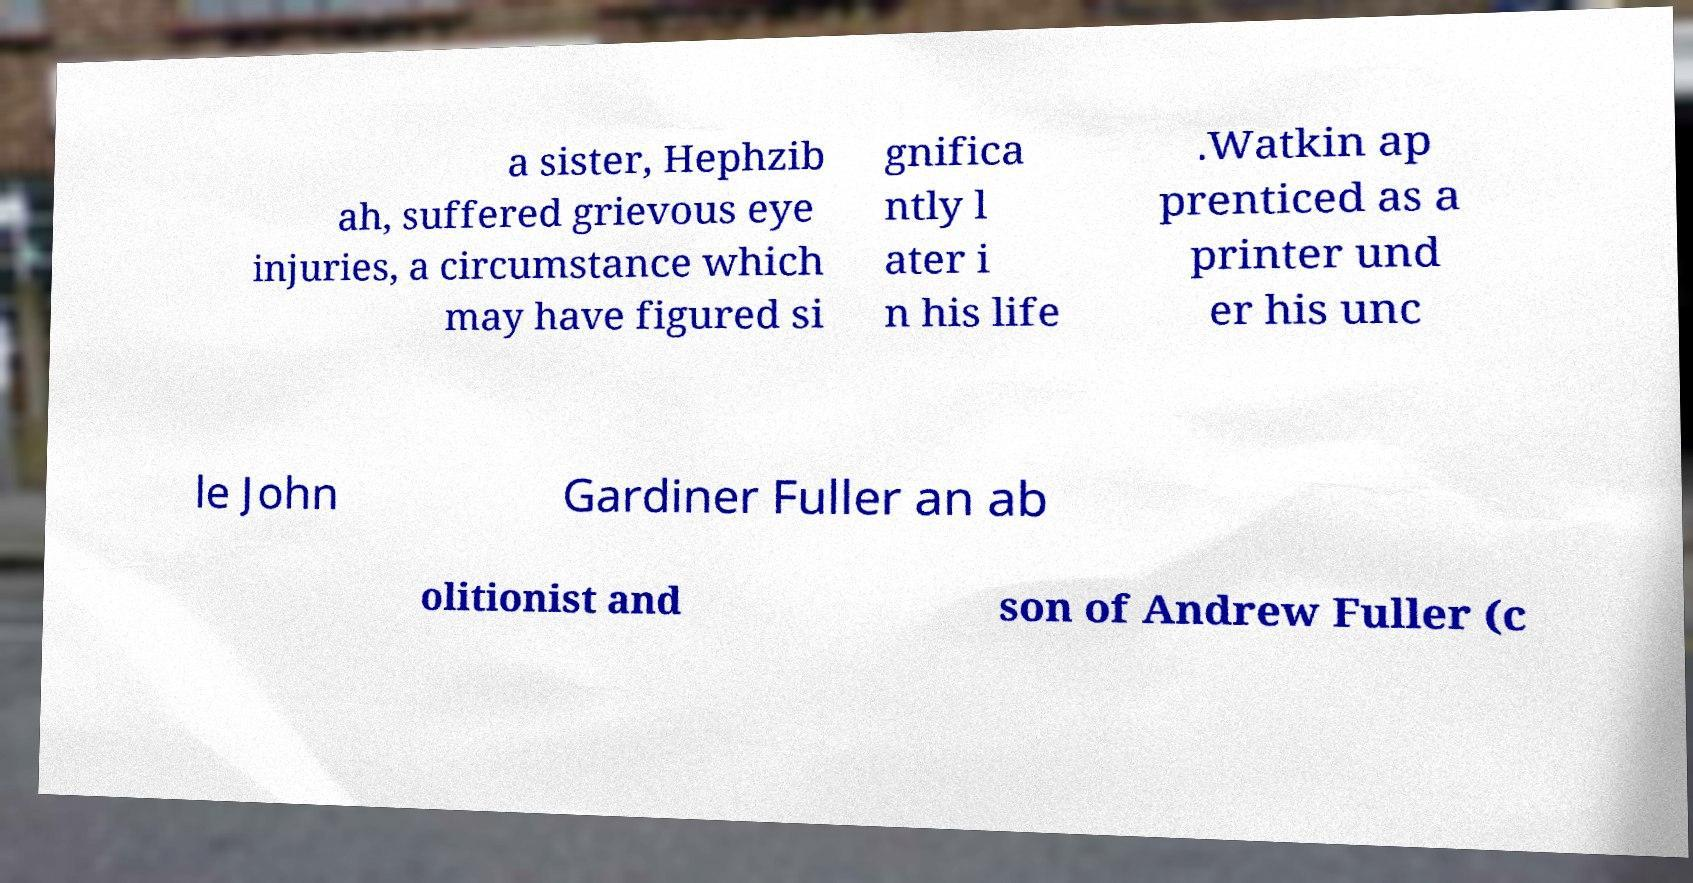Please read and relay the text visible in this image. What does it say? a sister, Hephzib ah, suffered grievous eye injuries, a circumstance which may have figured si gnifica ntly l ater i n his life .Watkin ap prenticed as a printer und er his unc le John Gardiner Fuller an ab olitionist and son of Andrew Fuller (c 